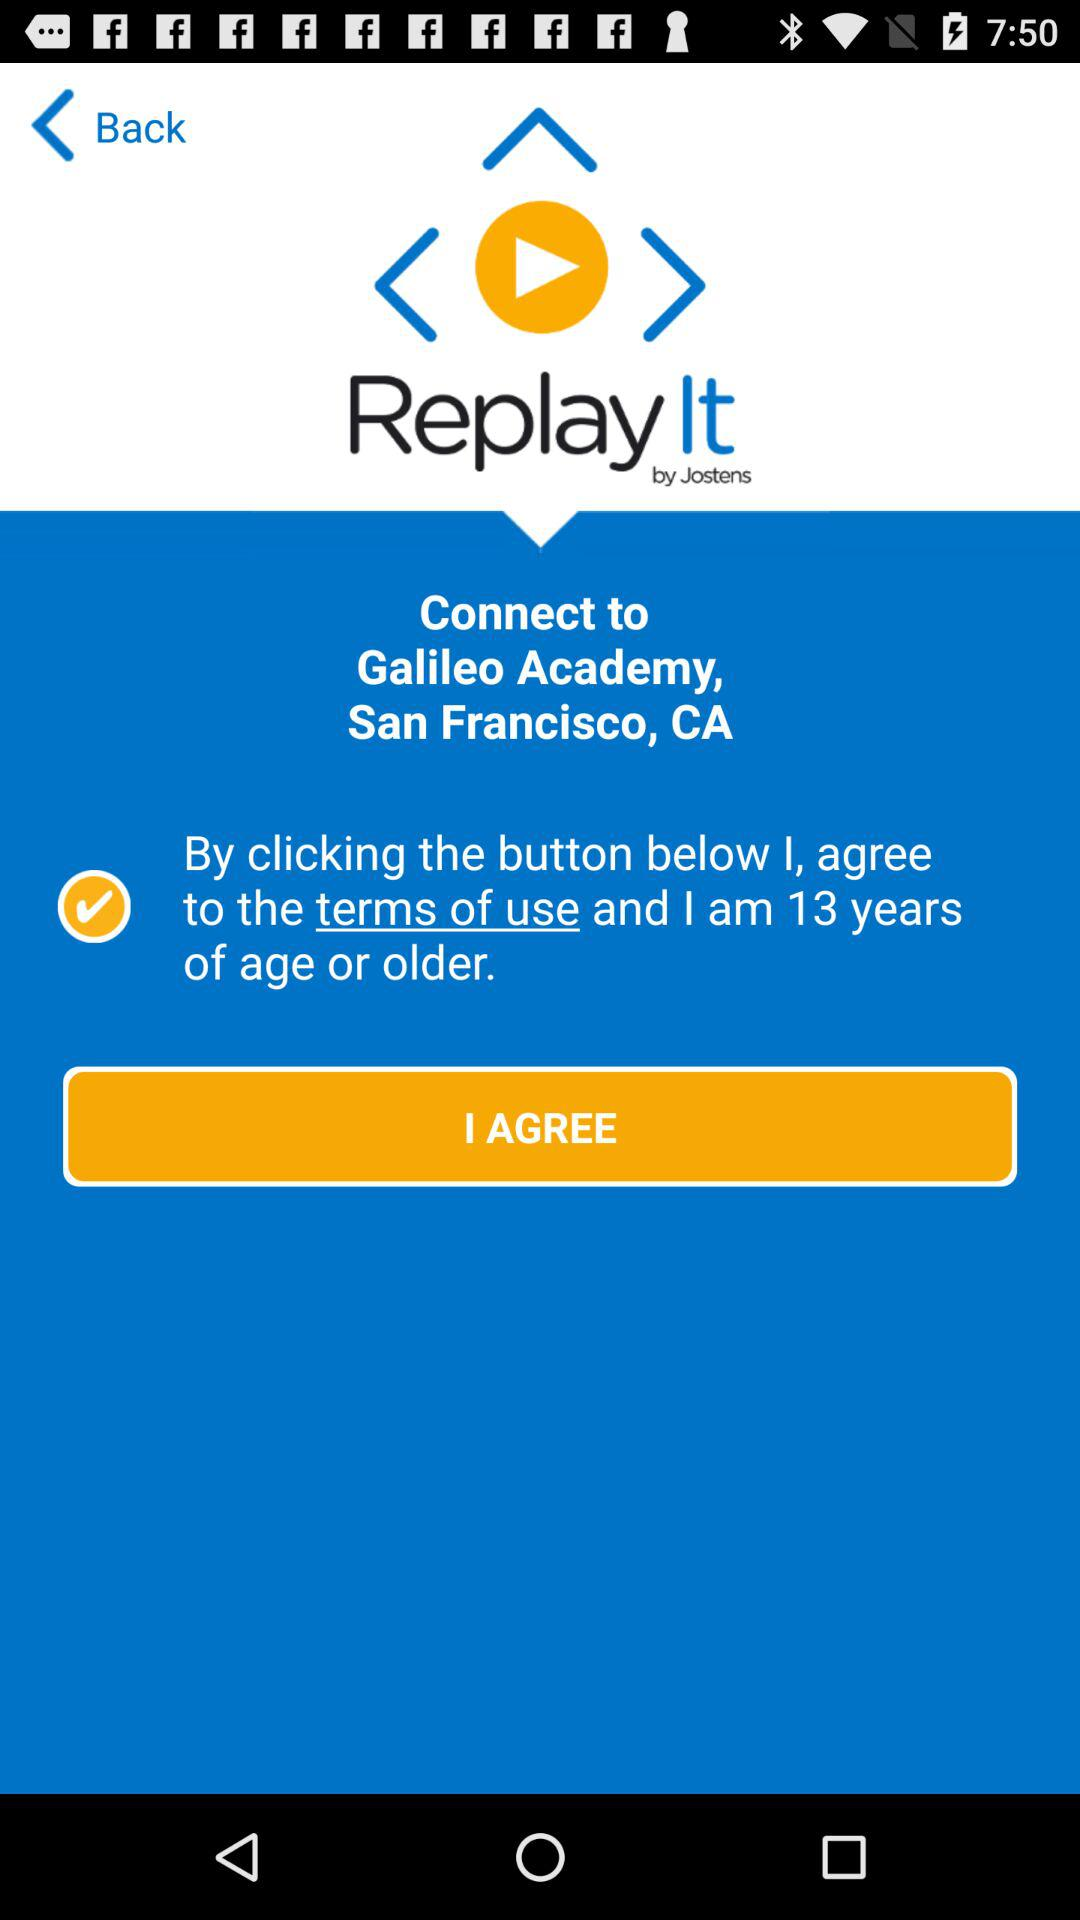What should be the minimum age of the user? The minimum age of the user should be 13 years. 